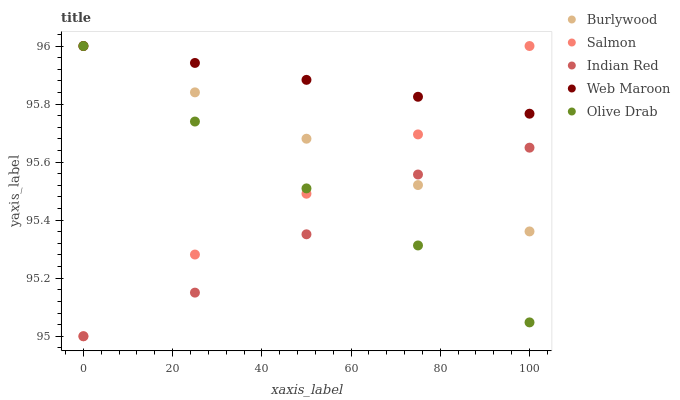Does Indian Red have the minimum area under the curve?
Answer yes or no. Yes. Does Web Maroon have the maximum area under the curve?
Answer yes or no. Yes. Does Salmon have the minimum area under the curve?
Answer yes or no. No. Does Salmon have the maximum area under the curve?
Answer yes or no. No. Is Web Maroon the smoothest?
Answer yes or no. Yes. Is Salmon the roughest?
Answer yes or no. Yes. Is Salmon the smoothest?
Answer yes or no. No. Is Web Maroon the roughest?
Answer yes or no. No. Does Salmon have the lowest value?
Answer yes or no. Yes. Does Web Maroon have the lowest value?
Answer yes or no. No. Does Olive Drab have the highest value?
Answer yes or no. Yes. Does Indian Red have the highest value?
Answer yes or no. No. Is Indian Red less than Web Maroon?
Answer yes or no. Yes. Is Web Maroon greater than Indian Red?
Answer yes or no. Yes. Does Salmon intersect Indian Red?
Answer yes or no. Yes. Is Salmon less than Indian Red?
Answer yes or no. No. Is Salmon greater than Indian Red?
Answer yes or no. No. Does Indian Red intersect Web Maroon?
Answer yes or no. No. 